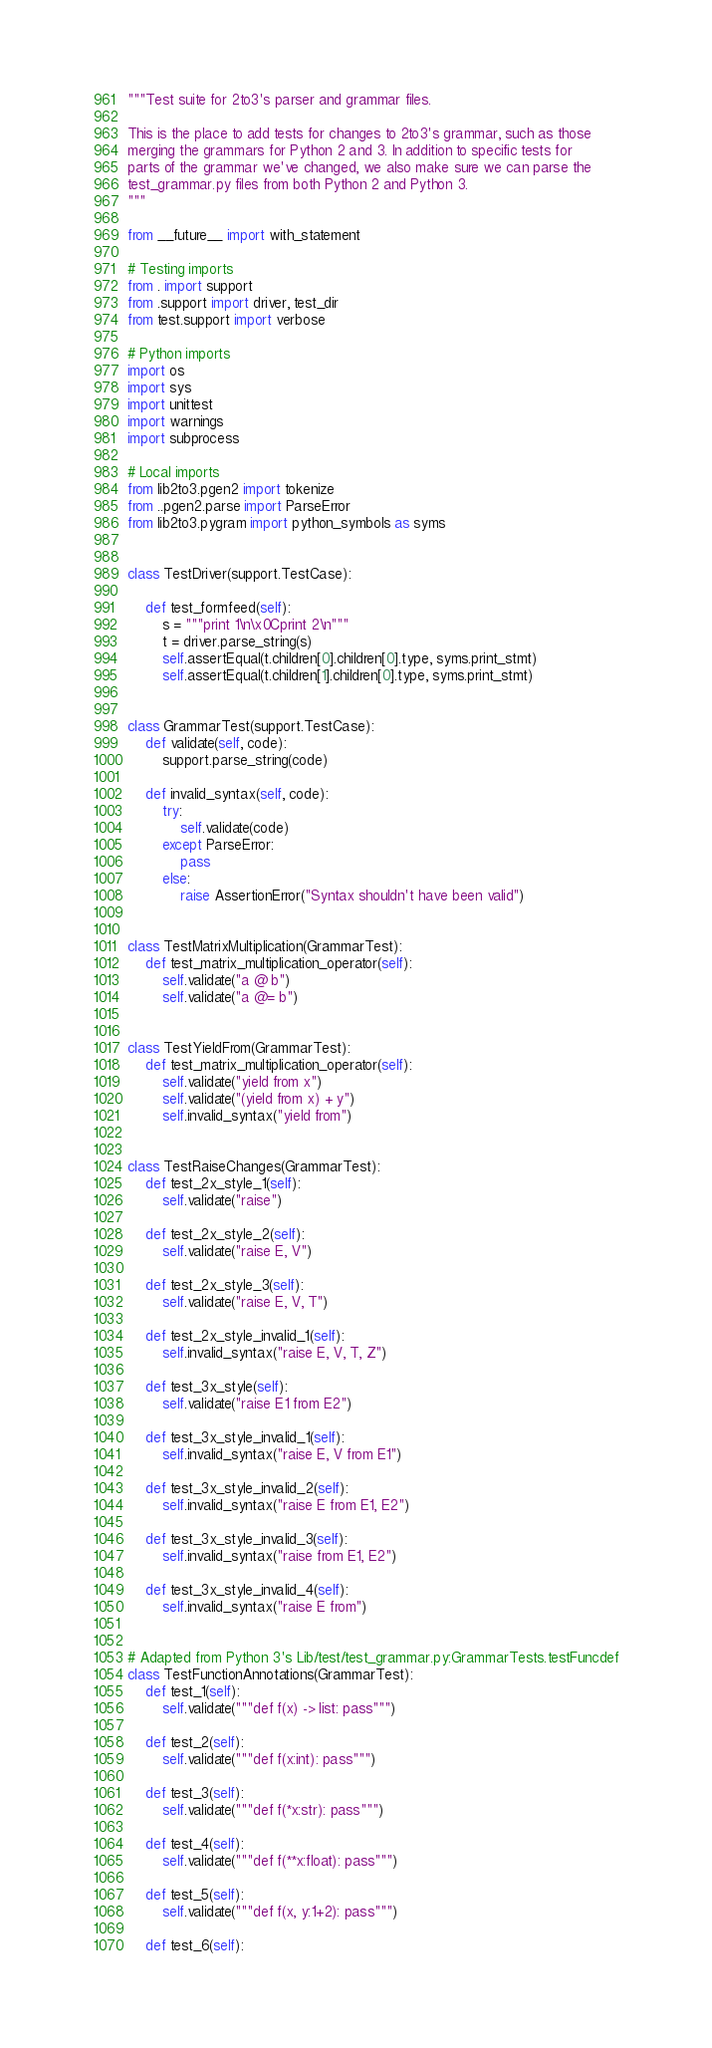<code> <loc_0><loc_0><loc_500><loc_500><_Python_>"""Test suite for 2to3's parser and grammar files.

This is the place to add tests for changes to 2to3's grammar, such as those
merging the grammars for Python 2 and 3. In addition to specific tests for
parts of the grammar we've changed, we also make sure we can parse the
test_grammar.py files from both Python 2 and Python 3.
"""

from __future__ import with_statement

# Testing imports
from . import support
from .support import driver, test_dir
from test.support import verbose

# Python imports
import os
import sys
import unittest
import warnings
import subprocess

# Local imports
from lib2to3.pgen2 import tokenize
from ..pgen2.parse import ParseError
from lib2to3.pygram import python_symbols as syms


class TestDriver(support.TestCase):

    def test_formfeed(self):
        s = """print 1\n\x0Cprint 2\n"""
        t = driver.parse_string(s)
        self.assertEqual(t.children[0].children[0].type, syms.print_stmt)
        self.assertEqual(t.children[1].children[0].type, syms.print_stmt)


class GrammarTest(support.TestCase):
    def validate(self, code):
        support.parse_string(code)

    def invalid_syntax(self, code):
        try:
            self.validate(code)
        except ParseError:
            pass
        else:
            raise AssertionError("Syntax shouldn't have been valid")


class TestMatrixMultiplication(GrammarTest):
    def test_matrix_multiplication_operator(self):
        self.validate("a @ b")
        self.validate("a @= b")


class TestYieldFrom(GrammarTest):
    def test_matrix_multiplication_operator(self):
        self.validate("yield from x")
        self.validate("(yield from x) + y")
        self.invalid_syntax("yield from")


class TestRaiseChanges(GrammarTest):
    def test_2x_style_1(self):
        self.validate("raise")

    def test_2x_style_2(self):
        self.validate("raise E, V")

    def test_2x_style_3(self):
        self.validate("raise E, V, T")

    def test_2x_style_invalid_1(self):
        self.invalid_syntax("raise E, V, T, Z")

    def test_3x_style(self):
        self.validate("raise E1 from E2")

    def test_3x_style_invalid_1(self):
        self.invalid_syntax("raise E, V from E1")

    def test_3x_style_invalid_2(self):
        self.invalid_syntax("raise E from E1, E2")

    def test_3x_style_invalid_3(self):
        self.invalid_syntax("raise from E1, E2")

    def test_3x_style_invalid_4(self):
        self.invalid_syntax("raise E from")


# Adapted from Python 3's Lib/test/test_grammar.py:GrammarTests.testFuncdef
class TestFunctionAnnotations(GrammarTest):
    def test_1(self):
        self.validate("""def f(x) -> list: pass""")

    def test_2(self):
        self.validate("""def f(x:int): pass""")

    def test_3(self):
        self.validate("""def f(*x:str): pass""")

    def test_4(self):
        self.validate("""def f(**x:float): pass""")

    def test_5(self):
        self.validate("""def f(x, y:1+2): pass""")

    def test_6(self):</code> 